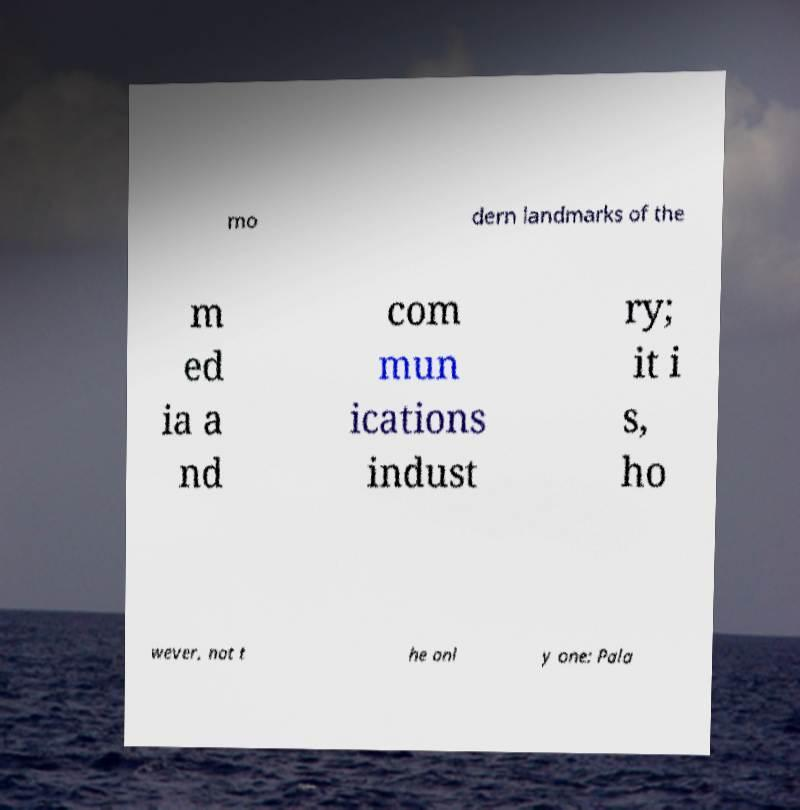What messages or text are displayed in this image? I need them in a readable, typed format. mo dern landmarks of the m ed ia a nd com mun ications indust ry; it i s, ho wever, not t he onl y one: Pala 